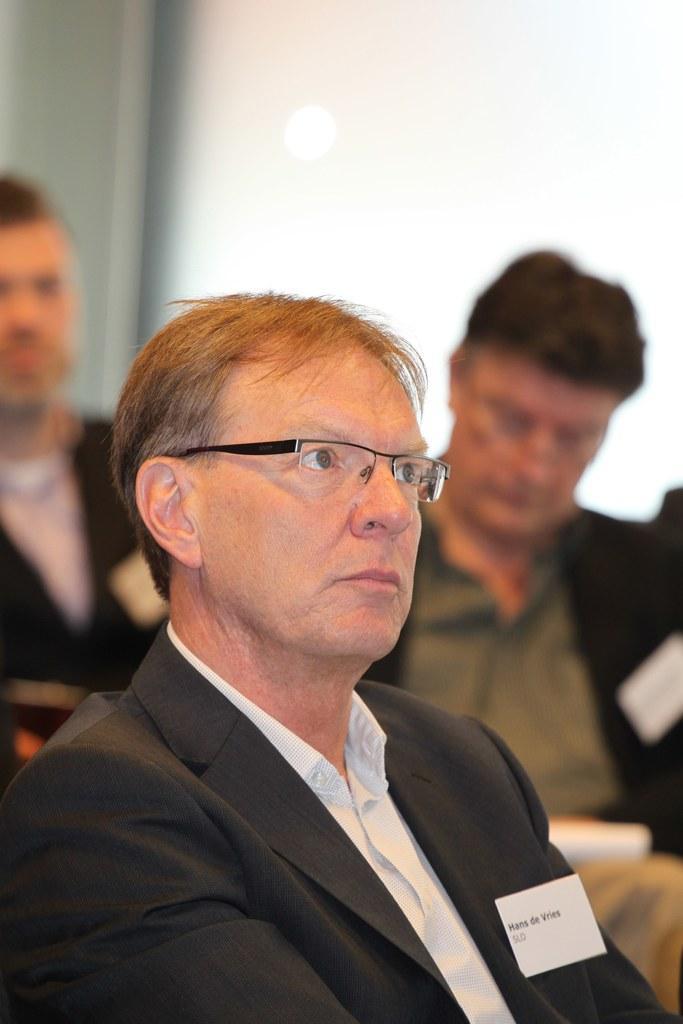Please provide a concise description of this image. In this image there are people sitting on chairs, in the background it is blurred. 